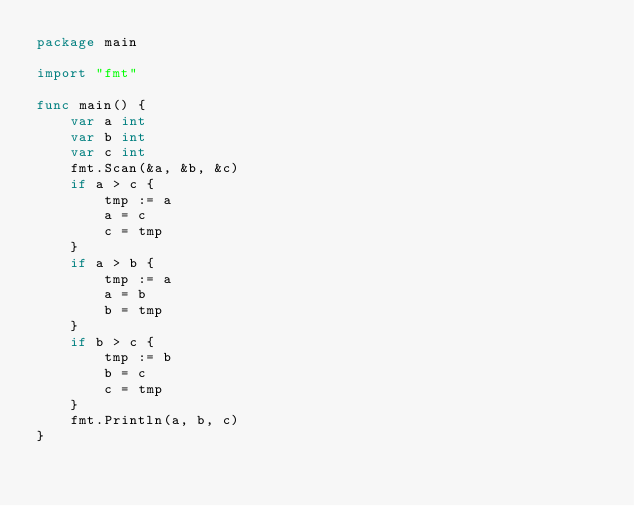Convert code to text. <code><loc_0><loc_0><loc_500><loc_500><_Go_>package main

import "fmt"

func main() {
	var a int
	var b int
	var c int
	fmt.Scan(&a, &b, &c)
	if a > c {
		tmp := a
		a = c
		c = tmp
	}
	if a > b {
		tmp := a
		a = b
		b = tmp
	}
	if b > c {
		tmp := b
		b = c
		c = tmp
	}
	fmt.Println(a, b, c)
}
</code> 